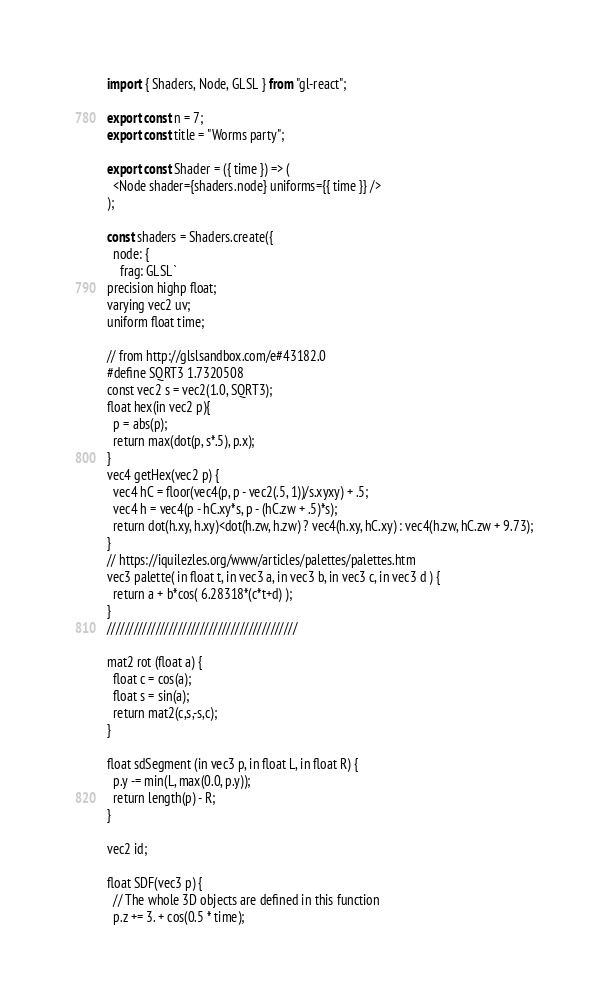<code> <loc_0><loc_0><loc_500><loc_500><_JavaScript_>

import { Shaders, Node, GLSL } from "gl-react";

export const n = 7;
export const title = "Worms party";

export const Shader = ({ time }) => (
  <Node shader={shaders.node} uniforms={{ time }} />
);

const shaders = Shaders.create({
  node: {
    frag: GLSL`
precision highp float;
varying vec2 uv;
uniform float time;

// from http://glslsandbox.com/e#43182.0
#define SQRT3 1.7320508
const vec2 s = vec2(1.0, SQRT3);
float hex(in vec2 p){
  p = abs(p);
  return max(dot(p, s*.5), p.x);
}
vec4 getHex(vec2 p) {
  vec4 hC = floor(vec4(p, p - vec2(.5, 1))/s.xyxy) + .5;
  vec4 h = vec4(p - hC.xy*s, p - (hC.zw + .5)*s);
  return dot(h.xy, h.xy)<dot(h.zw, h.zw) ? vec4(h.xy, hC.xy) : vec4(h.zw, hC.zw + 9.73);
}
// https://iquilezles.org/www/articles/palettes/palettes.htm
vec3 palette( in float t, in vec3 a, in vec3 b, in vec3 c, in vec3 d ) {
  return a + b*cos( 6.28318*(c*t+d) );
}
///////////////////////////////////////////

mat2 rot (float a) {
  float c = cos(a);
  float s = sin(a);
  return mat2(c,s,-s,c);
}

float sdSegment (in vec3 p, in float L, in float R) {
  p.y -= min(L, max(0.0, p.y));
  return length(p) - R;
}

vec2 id;

float SDF(vec3 p) {
  // The whole 3D objects are defined in this function
  p.z += 3. + cos(0.5 * time);</code> 